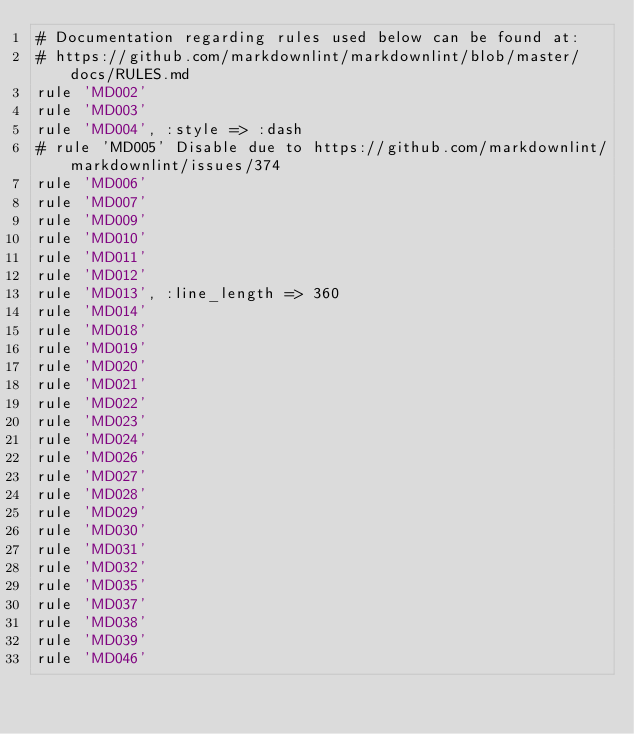<code> <loc_0><loc_0><loc_500><loc_500><_Ruby_># Documentation regarding rules used below can be found at:
# https://github.com/markdownlint/markdownlint/blob/master/docs/RULES.md
rule 'MD002'
rule 'MD003'
rule 'MD004', :style => :dash
# rule 'MD005' Disable due to https://github.com/markdownlint/markdownlint/issues/374
rule 'MD006'
rule 'MD007'
rule 'MD009'
rule 'MD010'
rule 'MD011'
rule 'MD012'
rule 'MD013', :line_length => 360
rule 'MD014'
rule 'MD018'
rule 'MD019'
rule 'MD020'
rule 'MD021'
rule 'MD022'
rule 'MD023'
rule 'MD024'
rule 'MD026'
rule 'MD027'
rule 'MD028'
rule 'MD029'
rule 'MD030'
rule 'MD031'
rule 'MD032'
rule 'MD035'
rule 'MD037'
rule 'MD038'
rule 'MD039'
rule 'MD046'
</code> 